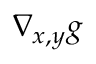Convert formula to latex. <formula><loc_0><loc_0><loc_500><loc_500>\nabla _ { x , y } g</formula> 